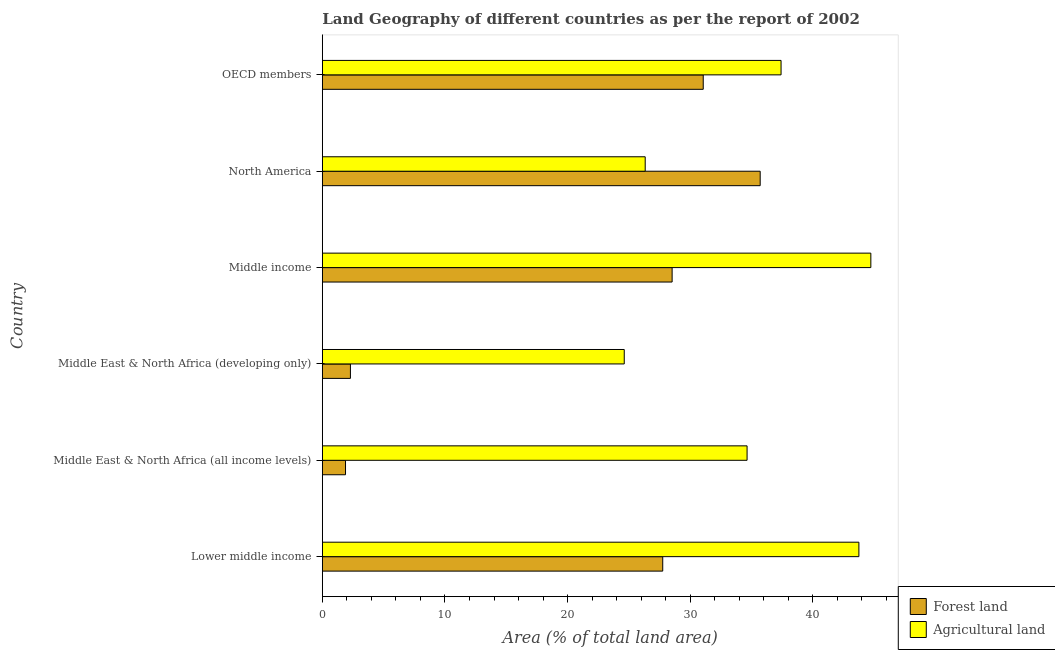Are the number of bars per tick equal to the number of legend labels?
Your response must be concise. Yes. How many bars are there on the 3rd tick from the top?
Provide a short and direct response. 2. How many bars are there on the 4th tick from the bottom?
Your answer should be compact. 2. What is the label of the 5th group of bars from the top?
Make the answer very short. Middle East & North Africa (all income levels). What is the percentage of land area under agriculture in North America?
Your answer should be compact. 26.33. Across all countries, what is the maximum percentage of land area under forests?
Your answer should be very brief. 35.7. Across all countries, what is the minimum percentage of land area under agriculture?
Your answer should be very brief. 24.62. In which country was the percentage of land area under agriculture minimum?
Make the answer very short. Middle East & North Africa (developing only). What is the total percentage of land area under agriculture in the graph?
Offer a very short reply. 211.45. What is the difference between the percentage of land area under forests in Middle East & North Africa (all income levels) and that in OECD members?
Your answer should be very brief. -29.17. What is the difference between the percentage of land area under agriculture in North America and the percentage of land area under forests in Middle East & North Africa (developing only)?
Provide a short and direct response. 24.04. What is the average percentage of land area under forests per country?
Ensure brevity in your answer.  21.2. What is the difference between the percentage of land area under forests and percentage of land area under agriculture in Middle East & North Africa (developing only)?
Provide a succinct answer. -22.33. In how many countries, is the percentage of land area under forests greater than 40 %?
Ensure brevity in your answer.  0. What is the ratio of the percentage of land area under forests in Middle income to that in OECD members?
Provide a succinct answer. 0.92. Is the percentage of land area under forests in Middle income less than that in North America?
Your answer should be compact. Yes. What is the difference between the highest and the second highest percentage of land area under agriculture?
Ensure brevity in your answer.  0.97. What is the difference between the highest and the lowest percentage of land area under forests?
Offer a very short reply. 33.81. What does the 1st bar from the top in OECD members represents?
Provide a short and direct response. Agricultural land. What does the 2nd bar from the bottom in Lower middle income represents?
Your answer should be very brief. Agricultural land. How many bars are there?
Your answer should be very brief. 12. Are all the bars in the graph horizontal?
Your response must be concise. Yes. How many countries are there in the graph?
Offer a terse response. 6. What is the difference between two consecutive major ticks on the X-axis?
Provide a succinct answer. 10. Are the values on the major ticks of X-axis written in scientific E-notation?
Provide a short and direct response. No. Where does the legend appear in the graph?
Your answer should be very brief. Bottom right. How many legend labels are there?
Keep it short and to the point. 2. What is the title of the graph?
Provide a succinct answer. Land Geography of different countries as per the report of 2002. What is the label or title of the X-axis?
Provide a short and direct response. Area (% of total land area). What is the label or title of the Y-axis?
Give a very brief answer. Country. What is the Area (% of total land area) of Forest land in Lower middle income?
Make the answer very short. 27.76. What is the Area (% of total land area) of Agricultural land in Lower middle income?
Provide a succinct answer. 43.75. What is the Area (% of total land area) of Forest land in Middle East & North Africa (all income levels)?
Offer a terse response. 1.89. What is the Area (% of total land area) of Agricultural land in Middle East & North Africa (all income levels)?
Provide a succinct answer. 34.63. What is the Area (% of total land area) of Forest land in Middle East & North Africa (developing only)?
Your answer should be very brief. 2.29. What is the Area (% of total land area) of Agricultural land in Middle East & North Africa (developing only)?
Provide a short and direct response. 24.62. What is the Area (% of total land area) in Forest land in Middle income?
Provide a succinct answer. 28.52. What is the Area (% of total land area) of Agricultural land in Middle income?
Your answer should be very brief. 44.72. What is the Area (% of total land area) in Forest land in North America?
Provide a succinct answer. 35.7. What is the Area (% of total land area) of Agricultural land in North America?
Your answer should be very brief. 26.33. What is the Area (% of total land area) of Forest land in OECD members?
Provide a short and direct response. 31.06. What is the Area (% of total land area) of Agricultural land in OECD members?
Your answer should be compact. 37.4. Across all countries, what is the maximum Area (% of total land area) in Forest land?
Offer a terse response. 35.7. Across all countries, what is the maximum Area (% of total land area) of Agricultural land?
Your answer should be very brief. 44.72. Across all countries, what is the minimum Area (% of total land area) of Forest land?
Make the answer very short. 1.89. Across all countries, what is the minimum Area (% of total land area) in Agricultural land?
Make the answer very short. 24.62. What is the total Area (% of total land area) of Forest land in the graph?
Keep it short and to the point. 127.22. What is the total Area (% of total land area) of Agricultural land in the graph?
Your answer should be compact. 211.45. What is the difference between the Area (% of total land area) in Forest land in Lower middle income and that in Middle East & North Africa (all income levels)?
Your answer should be very brief. 25.86. What is the difference between the Area (% of total land area) of Agricultural land in Lower middle income and that in Middle East & North Africa (all income levels)?
Offer a very short reply. 9.12. What is the difference between the Area (% of total land area) of Forest land in Lower middle income and that in Middle East & North Africa (developing only)?
Keep it short and to the point. 25.47. What is the difference between the Area (% of total land area) in Agricultural land in Lower middle income and that in Middle East & North Africa (developing only)?
Ensure brevity in your answer.  19.13. What is the difference between the Area (% of total land area) of Forest land in Lower middle income and that in Middle income?
Keep it short and to the point. -0.77. What is the difference between the Area (% of total land area) of Agricultural land in Lower middle income and that in Middle income?
Your answer should be very brief. -0.97. What is the difference between the Area (% of total land area) of Forest land in Lower middle income and that in North America?
Offer a terse response. -7.95. What is the difference between the Area (% of total land area) in Agricultural land in Lower middle income and that in North America?
Your answer should be compact. 17.42. What is the difference between the Area (% of total land area) in Forest land in Lower middle income and that in OECD members?
Offer a terse response. -3.3. What is the difference between the Area (% of total land area) of Agricultural land in Lower middle income and that in OECD members?
Your response must be concise. 6.35. What is the difference between the Area (% of total land area) of Forest land in Middle East & North Africa (all income levels) and that in Middle East & North Africa (developing only)?
Provide a short and direct response. -0.4. What is the difference between the Area (% of total land area) in Agricultural land in Middle East & North Africa (all income levels) and that in Middle East & North Africa (developing only)?
Your answer should be compact. 10.02. What is the difference between the Area (% of total land area) of Forest land in Middle East & North Africa (all income levels) and that in Middle income?
Offer a very short reply. -26.63. What is the difference between the Area (% of total land area) of Agricultural land in Middle East & North Africa (all income levels) and that in Middle income?
Give a very brief answer. -10.09. What is the difference between the Area (% of total land area) of Forest land in Middle East & North Africa (all income levels) and that in North America?
Your answer should be very brief. -33.81. What is the difference between the Area (% of total land area) in Agricultural land in Middle East & North Africa (all income levels) and that in North America?
Give a very brief answer. 8.31. What is the difference between the Area (% of total land area) in Forest land in Middle East & North Africa (all income levels) and that in OECD members?
Offer a terse response. -29.17. What is the difference between the Area (% of total land area) in Agricultural land in Middle East & North Africa (all income levels) and that in OECD members?
Ensure brevity in your answer.  -2.77. What is the difference between the Area (% of total land area) of Forest land in Middle East & North Africa (developing only) and that in Middle income?
Provide a short and direct response. -26.23. What is the difference between the Area (% of total land area) of Agricultural land in Middle East & North Africa (developing only) and that in Middle income?
Give a very brief answer. -20.11. What is the difference between the Area (% of total land area) in Forest land in Middle East & North Africa (developing only) and that in North America?
Provide a short and direct response. -33.41. What is the difference between the Area (% of total land area) of Agricultural land in Middle East & North Africa (developing only) and that in North America?
Your answer should be very brief. -1.71. What is the difference between the Area (% of total land area) in Forest land in Middle East & North Africa (developing only) and that in OECD members?
Give a very brief answer. -28.77. What is the difference between the Area (% of total land area) in Agricultural land in Middle East & North Africa (developing only) and that in OECD members?
Your answer should be very brief. -12.79. What is the difference between the Area (% of total land area) in Forest land in Middle income and that in North America?
Give a very brief answer. -7.18. What is the difference between the Area (% of total land area) in Agricultural land in Middle income and that in North America?
Your answer should be compact. 18.4. What is the difference between the Area (% of total land area) of Forest land in Middle income and that in OECD members?
Provide a succinct answer. -2.54. What is the difference between the Area (% of total land area) of Agricultural land in Middle income and that in OECD members?
Offer a very short reply. 7.32. What is the difference between the Area (% of total land area) of Forest land in North America and that in OECD members?
Ensure brevity in your answer.  4.64. What is the difference between the Area (% of total land area) in Agricultural land in North America and that in OECD members?
Offer a terse response. -11.08. What is the difference between the Area (% of total land area) of Forest land in Lower middle income and the Area (% of total land area) of Agricultural land in Middle East & North Africa (all income levels)?
Make the answer very short. -6.88. What is the difference between the Area (% of total land area) in Forest land in Lower middle income and the Area (% of total land area) in Agricultural land in Middle East & North Africa (developing only)?
Provide a short and direct response. 3.14. What is the difference between the Area (% of total land area) of Forest land in Lower middle income and the Area (% of total land area) of Agricultural land in Middle income?
Your answer should be compact. -16.97. What is the difference between the Area (% of total land area) of Forest land in Lower middle income and the Area (% of total land area) of Agricultural land in North America?
Provide a succinct answer. 1.43. What is the difference between the Area (% of total land area) of Forest land in Lower middle income and the Area (% of total land area) of Agricultural land in OECD members?
Your answer should be compact. -9.65. What is the difference between the Area (% of total land area) in Forest land in Middle East & North Africa (all income levels) and the Area (% of total land area) in Agricultural land in Middle East & North Africa (developing only)?
Give a very brief answer. -22.73. What is the difference between the Area (% of total land area) of Forest land in Middle East & North Africa (all income levels) and the Area (% of total land area) of Agricultural land in Middle income?
Your answer should be compact. -42.83. What is the difference between the Area (% of total land area) in Forest land in Middle East & North Africa (all income levels) and the Area (% of total land area) in Agricultural land in North America?
Provide a succinct answer. -24.43. What is the difference between the Area (% of total land area) of Forest land in Middle East & North Africa (all income levels) and the Area (% of total land area) of Agricultural land in OECD members?
Your response must be concise. -35.51. What is the difference between the Area (% of total land area) of Forest land in Middle East & North Africa (developing only) and the Area (% of total land area) of Agricultural land in Middle income?
Your answer should be very brief. -42.43. What is the difference between the Area (% of total land area) of Forest land in Middle East & North Africa (developing only) and the Area (% of total land area) of Agricultural land in North America?
Your response must be concise. -24.04. What is the difference between the Area (% of total land area) of Forest land in Middle East & North Africa (developing only) and the Area (% of total land area) of Agricultural land in OECD members?
Give a very brief answer. -35.11. What is the difference between the Area (% of total land area) in Forest land in Middle income and the Area (% of total land area) in Agricultural land in North America?
Provide a succinct answer. 2.2. What is the difference between the Area (% of total land area) of Forest land in Middle income and the Area (% of total land area) of Agricultural land in OECD members?
Make the answer very short. -8.88. What is the difference between the Area (% of total land area) in Forest land in North America and the Area (% of total land area) in Agricultural land in OECD members?
Your answer should be very brief. -1.7. What is the average Area (% of total land area) of Forest land per country?
Provide a succinct answer. 21.2. What is the average Area (% of total land area) of Agricultural land per country?
Provide a succinct answer. 35.24. What is the difference between the Area (% of total land area) of Forest land and Area (% of total land area) of Agricultural land in Lower middle income?
Keep it short and to the point. -15.99. What is the difference between the Area (% of total land area) of Forest land and Area (% of total land area) of Agricultural land in Middle East & North Africa (all income levels)?
Offer a very short reply. -32.74. What is the difference between the Area (% of total land area) of Forest land and Area (% of total land area) of Agricultural land in Middle East & North Africa (developing only)?
Your response must be concise. -22.33. What is the difference between the Area (% of total land area) of Forest land and Area (% of total land area) of Agricultural land in Middle income?
Provide a succinct answer. -16.2. What is the difference between the Area (% of total land area) of Forest land and Area (% of total land area) of Agricultural land in North America?
Ensure brevity in your answer.  9.38. What is the difference between the Area (% of total land area) in Forest land and Area (% of total land area) in Agricultural land in OECD members?
Give a very brief answer. -6.35. What is the ratio of the Area (% of total land area) of Forest land in Lower middle income to that in Middle East & North Africa (all income levels)?
Make the answer very short. 14.68. What is the ratio of the Area (% of total land area) in Agricultural land in Lower middle income to that in Middle East & North Africa (all income levels)?
Provide a short and direct response. 1.26. What is the ratio of the Area (% of total land area) of Forest land in Lower middle income to that in Middle East & North Africa (developing only)?
Provide a short and direct response. 12.12. What is the ratio of the Area (% of total land area) of Agricultural land in Lower middle income to that in Middle East & North Africa (developing only)?
Your answer should be compact. 1.78. What is the ratio of the Area (% of total land area) in Forest land in Lower middle income to that in Middle income?
Keep it short and to the point. 0.97. What is the ratio of the Area (% of total land area) in Agricultural land in Lower middle income to that in Middle income?
Give a very brief answer. 0.98. What is the ratio of the Area (% of total land area) in Forest land in Lower middle income to that in North America?
Make the answer very short. 0.78. What is the ratio of the Area (% of total land area) in Agricultural land in Lower middle income to that in North America?
Ensure brevity in your answer.  1.66. What is the ratio of the Area (% of total land area) in Forest land in Lower middle income to that in OECD members?
Keep it short and to the point. 0.89. What is the ratio of the Area (% of total land area) in Agricultural land in Lower middle income to that in OECD members?
Offer a terse response. 1.17. What is the ratio of the Area (% of total land area) in Forest land in Middle East & North Africa (all income levels) to that in Middle East & North Africa (developing only)?
Provide a short and direct response. 0.83. What is the ratio of the Area (% of total land area) of Agricultural land in Middle East & North Africa (all income levels) to that in Middle East & North Africa (developing only)?
Give a very brief answer. 1.41. What is the ratio of the Area (% of total land area) of Forest land in Middle East & North Africa (all income levels) to that in Middle income?
Keep it short and to the point. 0.07. What is the ratio of the Area (% of total land area) in Agricultural land in Middle East & North Africa (all income levels) to that in Middle income?
Provide a succinct answer. 0.77. What is the ratio of the Area (% of total land area) in Forest land in Middle East & North Africa (all income levels) to that in North America?
Provide a succinct answer. 0.05. What is the ratio of the Area (% of total land area) of Agricultural land in Middle East & North Africa (all income levels) to that in North America?
Offer a terse response. 1.32. What is the ratio of the Area (% of total land area) of Forest land in Middle East & North Africa (all income levels) to that in OECD members?
Provide a succinct answer. 0.06. What is the ratio of the Area (% of total land area) in Agricultural land in Middle East & North Africa (all income levels) to that in OECD members?
Offer a very short reply. 0.93. What is the ratio of the Area (% of total land area) in Forest land in Middle East & North Africa (developing only) to that in Middle income?
Keep it short and to the point. 0.08. What is the ratio of the Area (% of total land area) of Agricultural land in Middle East & North Africa (developing only) to that in Middle income?
Ensure brevity in your answer.  0.55. What is the ratio of the Area (% of total land area) in Forest land in Middle East & North Africa (developing only) to that in North America?
Your answer should be compact. 0.06. What is the ratio of the Area (% of total land area) of Agricultural land in Middle East & North Africa (developing only) to that in North America?
Keep it short and to the point. 0.94. What is the ratio of the Area (% of total land area) in Forest land in Middle East & North Africa (developing only) to that in OECD members?
Your answer should be compact. 0.07. What is the ratio of the Area (% of total land area) of Agricultural land in Middle East & North Africa (developing only) to that in OECD members?
Your response must be concise. 0.66. What is the ratio of the Area (% of total land area) in Forest land in Middle income to that in North America?
Give a very brief answer. 0.8. What is the ratio of the Area (% of total land area) of Agricultural land in Middle income to that in North America?
Provide a succinct answer. 1.7. What is the ratio of the Area (% of total land area) of Forest land in Middle income to that in OECD members?
Make the answer very short. 0.92. What is the ratio of the Area (% of total land area) of Agricultural land in Middle income to that in OECD members?
Offer a terse response. 1.2. What is the ratio of the Area (% of total land area) of Forest land in North America to that in OECD members?
Your answer should be compact. 1.15. What is the ratio of the Area (% of total land area) of Agricultural land in North America to that in OECD members?
Offer a very short reply. 0.7. What is the difference between the highest and the second highest Area (% of total land area) of Forest land?
Offer a terse response. 4.64. What is the difference between the highest and the second highest Area (% of total land area) in Agricultural land?
Keep it short and to the point. 0.97. What is the difference between the highest and the lowest Area (% of total land area) of Forest land?
Give a very brief answer. 33.81. What is the difference between the highest and the lowest Area (% of total land area) of Agricultural land?
Your answer should be compact. 20.11. 